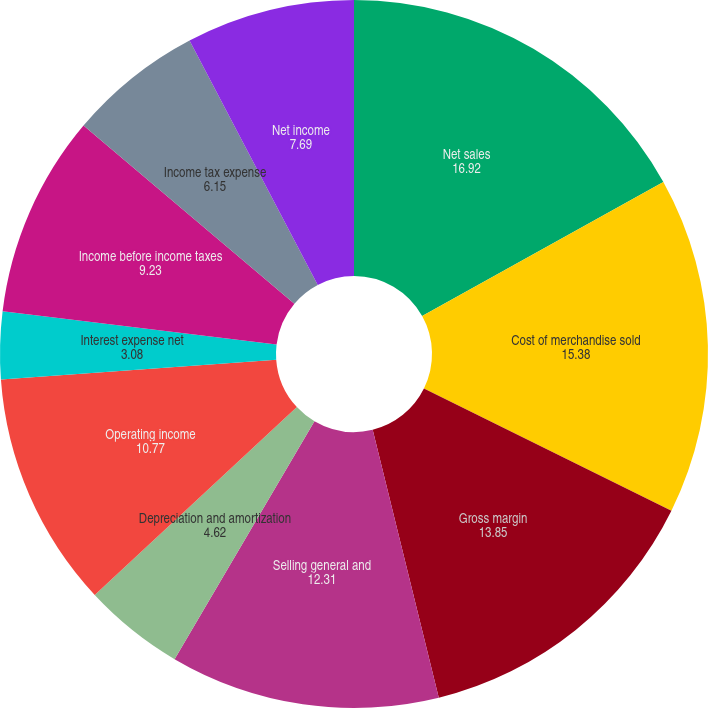<chart> <loc_0><loc_0><loc_500><loc_500><pie_chart><fcel>Net sales<fcel>Cost of merchandise sold<fcel>Gross margin<fcel>Selling general and<fcel>Depreciation and amortization<fcel>Operating income<fcel>Interest expense net<fcel>Income before income taxes<fcel>Income tax expense<fcel>Net income<nl><fcel>16.92%<fcel>15.38%<fcel>13.85%<fcel>12.31%<fcel>4.62%<fcel>10.77%<fcel>3.08%<fcel>9.23%<fcel>6.15%<fcel>7.69%<nl></chart> 